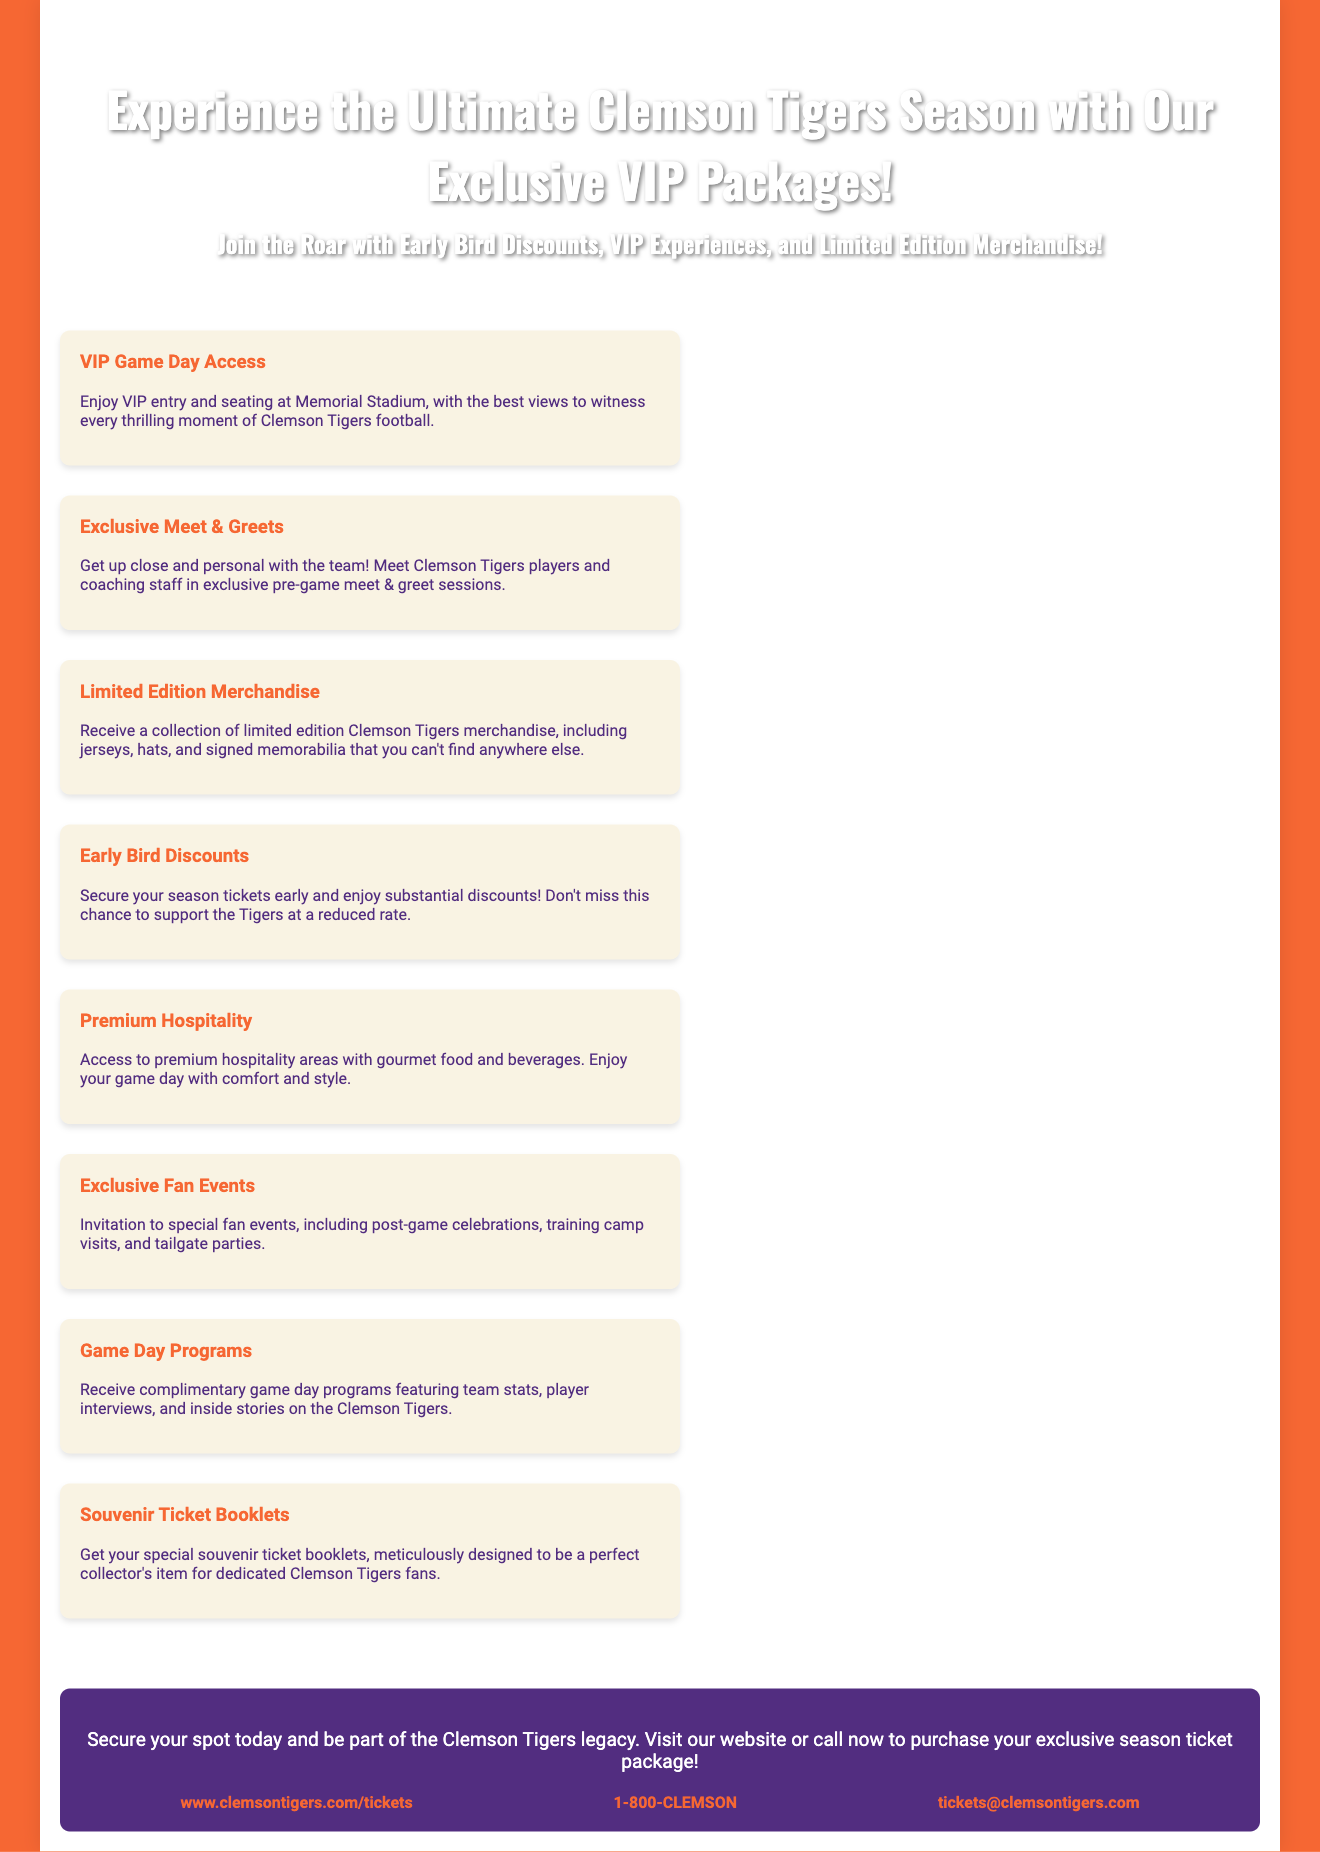What are the VIP Game Day experiences? The document lists VIP Game Day Access, Exclusive Meet & Greets, and Premium Hospitality as the main experiences.
Answer: VIP Game Day Access, Exclusive Meet & Greets, Premium Hospitality What discounts are offered for early purchases? The document states that early buyers can enjoy substantial discounts on season tickets.
Answer: Substantial discounts What types of limited edition merchandise are included? The document mentions jerseys, hats, and signed memorabilia as part of the limited edition merchandise collection.
Answer: Jerseys, hats, signed memorabilia What is one type of special event mentioned? The document specifies an invitation to special fan events like post-game celebrations and training camp visits.
Answer: Post-game celebrations How can fans secure their tickets? The document indicates that fans can secure tickets by visiting the website or calling a specific number.
Answer: Website or calling What type of hospitality is mentioned in the package? The document describes access to premium hospitality areas with gourmet food and beverages.
Answer: Premium hospitality areas How does the document invite fans to participate? The document encourages fans to secure their spot to be part of the Clemson Tigers legacy.
Answer: Secure your spot today What contact method is provided for inquiries? The document includes a telephone number, email address, and website link for contacting ticket services.
Answer: 1-800-CLEMSON, tickets@clemsontigers.com, www.clemsontigers.com/tickets What do the souvenir ticket booklets serve as? The document states that souvenir ticket booklets are designed to be a perfect collector's item for dedicated fans.
Answer: Collector's item 